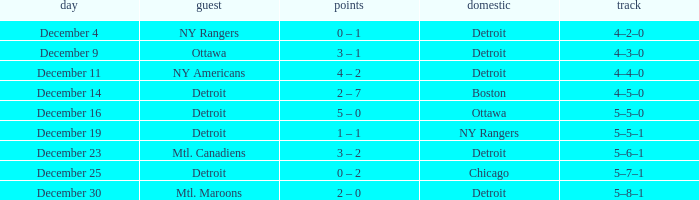What score has detroit as the home, and December 9 as the date? 3 – 1. 